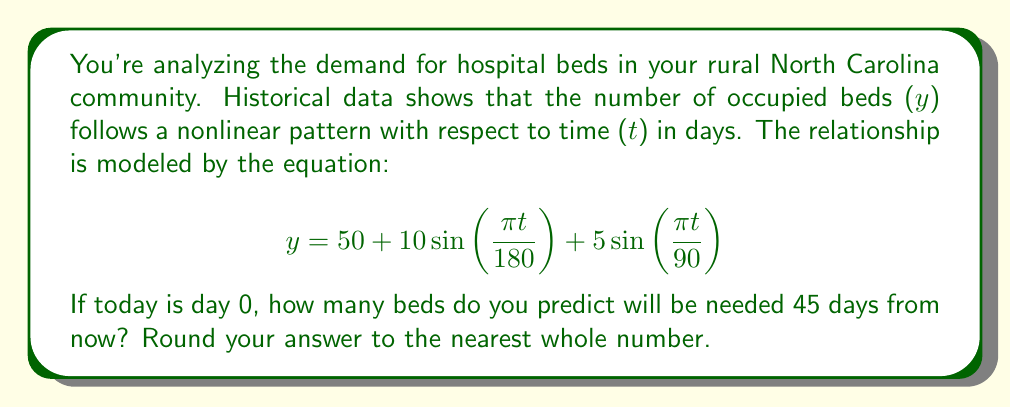Give your solution to this math problem. To solve this problem, we'll follow these steps:

1) We're given the equation:
   $$ y = 50 + 10\sin(\frac{\pi t}{180}) + 5\sin(\frac{\pi t}{90}) $$

2) We need to find y when t = 45 (45 days from now).

3) Let's substitute t = 45 into the equation:
   $$ y = 50 + 10\sin(\frac{\pi (45)}{180}) + 5\sin(\frac{\pi (45)}{90}) $$

4) Simplify the arguments of the sine functions:
   $$ y = 50 + 10\sin(\frac{\pi}{4}) + 5\sin(\frac{\pi}{2}) $$

5) Calculate the sine values:
   $\sin(\frac{\pi}{4}) = \frac{\sqrt{2}}{2} \approx 0.7071$
   $\sin(\frac{\pi}{2}) = 1$

6) Substitute these values:
   $$ y = 50 + 10(0.7071) + 5(1) $$

7) Calculate:
   $$ y = 50 + 7.071 + 5 = 62.071 $$

8) Round to the nearest whole number:
   $$ y \approx 62 $$

Therefore, 45 days from now, you predict that 62 beds will be needed.
Answer: 62 beds 